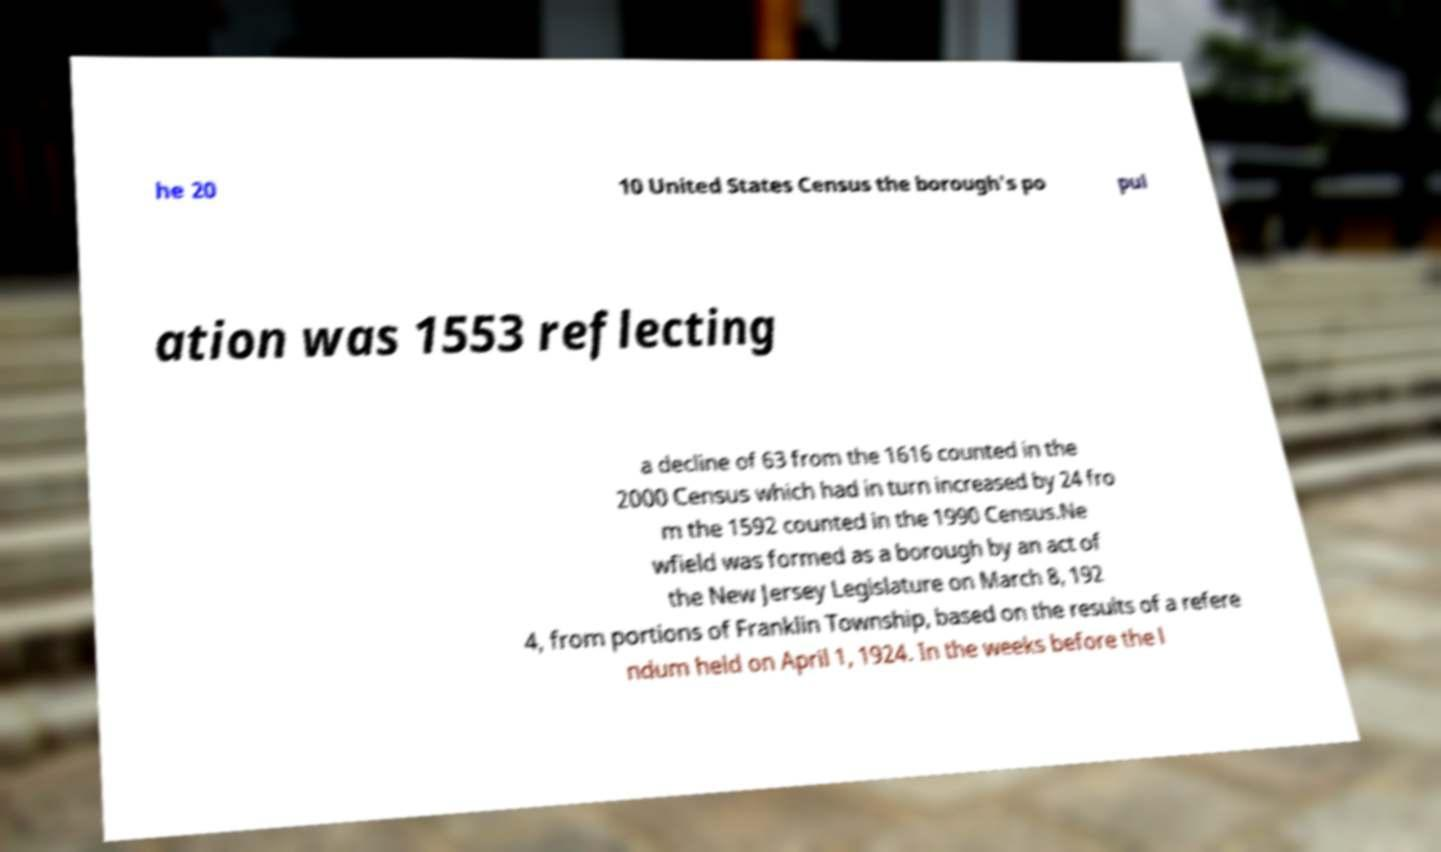There's text embedded in this image that I need extracted. Can you transcribe it verbatim? he 20 10 United States Census the borough's po pul ation was 1553 reflecting a decline of 63 from the 1616 counted in the 2000 Census which had in turn increased by 24 fro m the 1592 counted in the 1990 Census.Ne wfield was formed as a borough by an act of the New Jersey Legislature on March 8, 192 4, from portions of Franklin Township, based on the results of a refere ndum held on April 1, 1924. In the weeks before the l 